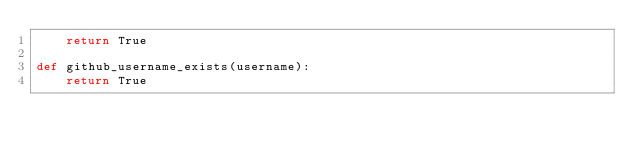Convert code to text. <code><loc_0><loc_0><loc_500><loc_500><_Python_>    return True

def github_username_exists(username):
    return True</code> 